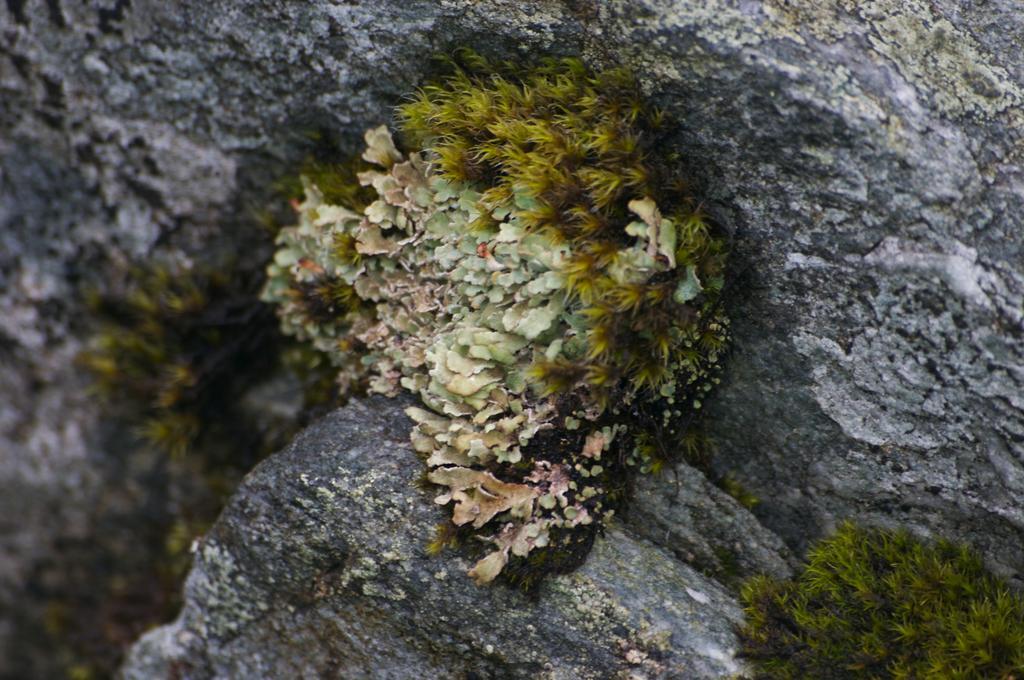Please provide a concise description of this image. In this image, we can see a plant on the rock. There is an another plant in the bottom right of the image. 